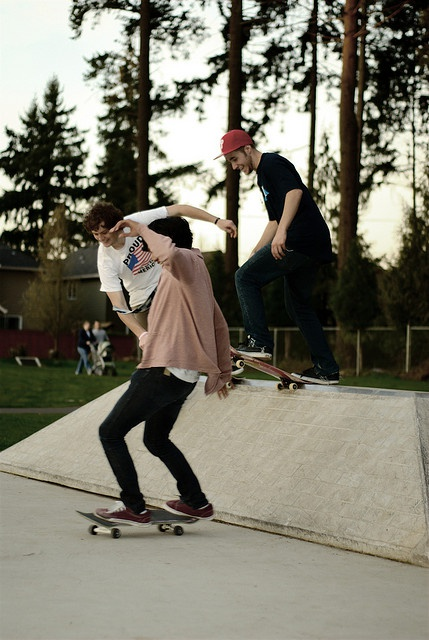Describe the objects in this image and their specific colors. I can see people in ivory, black, gray, and darkgray tones, people in ivory, black, tan, gray, and maroon tones, people in ivory, darkgray, black, lightgray, and tan tones, skateboard in ivory, black, gray, darkgray, and darkgreen tones, and skateboard in ivory, black, gray, and maroon tones in this image. 